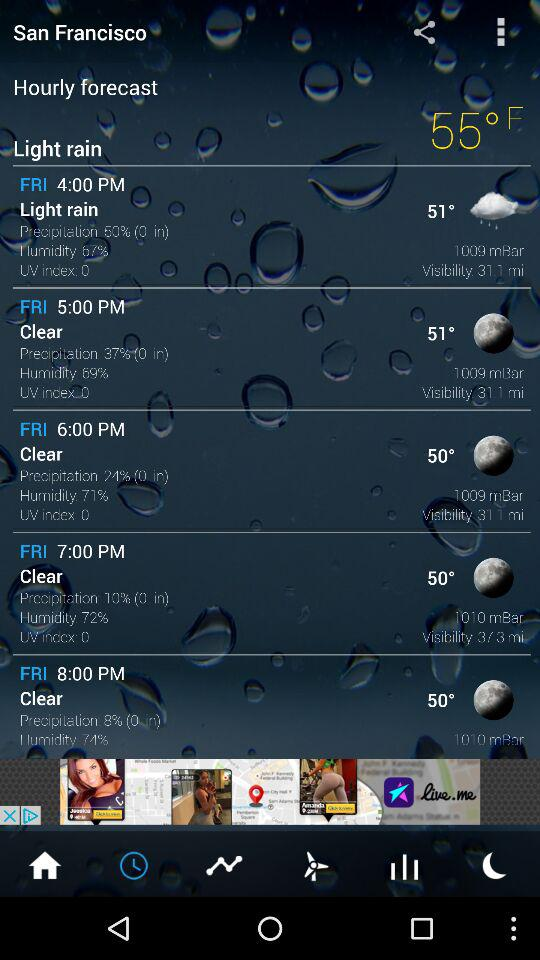What location's weather forecast is given? The weather forecast is given for San Francisco. 